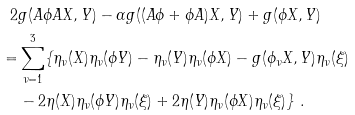<formula> <loc_0><loc_0><loc_500><loc_500>2 & g ( A \phi A X , Y ) - \alpha g ( ( A \phi + \phi A ) X , Y ) + g ( \phi X , Y ) \\ = & \sum _ { \nu = 1 } ^ { 3 } \{ \eta _ { \nu } ( X ) \eta _ { \nu } ( \phi Y ) - \eta _ { \nu } ( Y ) \eta _ { \nu } ( \phi X ) - g ( \phi _ { \nu } X , Y ) \eta _ { \nu } ( \xi ) \\ & - 2 \eta ( X ) \eta _ { \nu } ( \phi Y ) \eta _ { \nu } ( \xi ) + 2 \eta ( Y ) \eta _ { \nu } ( \phi X ) \eta _ { \nu } ( \xi ) \} \ .</formula> 